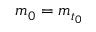<formula> <loc_0><loc_0><loc_500><loc_500>m _ { 0 } = m _ { t _ { 0 } }</formula> 